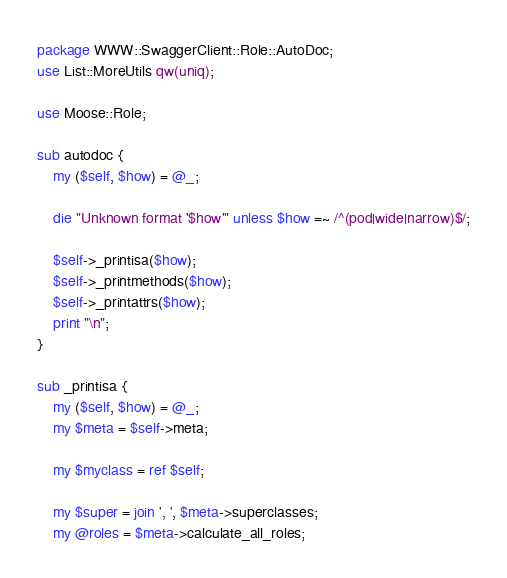<code> <loc_0><loc_0><loc_500><loc_500><_Perl_>package WWW::SwaggerClient::Role::AutoDoc;
use List::MoreUtils qw(uniq);

use Moose::Role;

sub autodoc {
	my ($self, $how) = @_;
	
	die "Unknown format '$how'" unless $how =~ /^(pod|wide|narrow)$/;
	
	$self->_printisa($how);
	$self->_printmethods($how);
	$self->_printattrs($how);
	print "\n";
}

sub _printisa {
	my ($self, $how) = @_;	
	my $meta = $self->meta;
	
	my $myclass = ref $self;
	
	my $super = join ', ', $meta->superclasses;
	my @roles = $meta->calculate_all_roles;</code> 